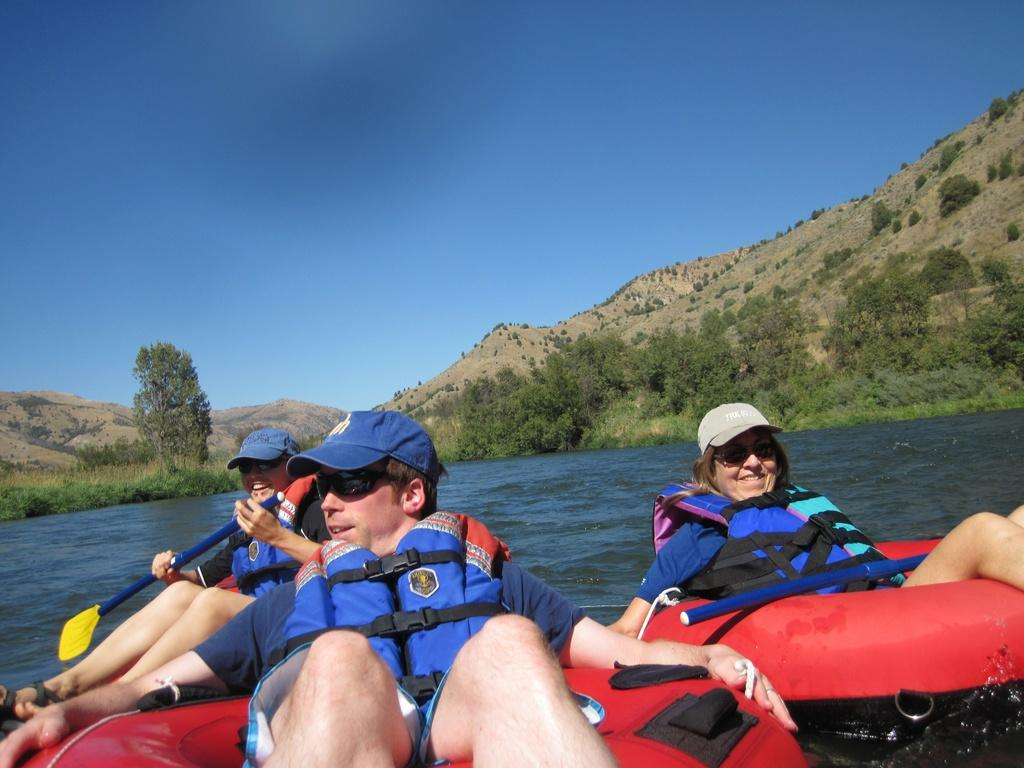What activity are the people in the image engaged in? The people in the image are rafting. What is the primary setting for this activity? There is water visible in the image. What type of natural environment can be seen in the image? There are trees and a hill in the image. What is visible in the sky in the image? Clouds are visible in the sky. Can you tell me which letter is being used by the people rafting in the image? There is no mention of a letter being used by the people rafting in the image. How many legs can be seen on the people rafting in the image? The number of legs visible in the image depends on the number of people rafting, but there is no specific count provided in the facts. What time of day is it in the image? The time of day is not specified in the facts, so we cannot determine if it is afternoon or any other time. 